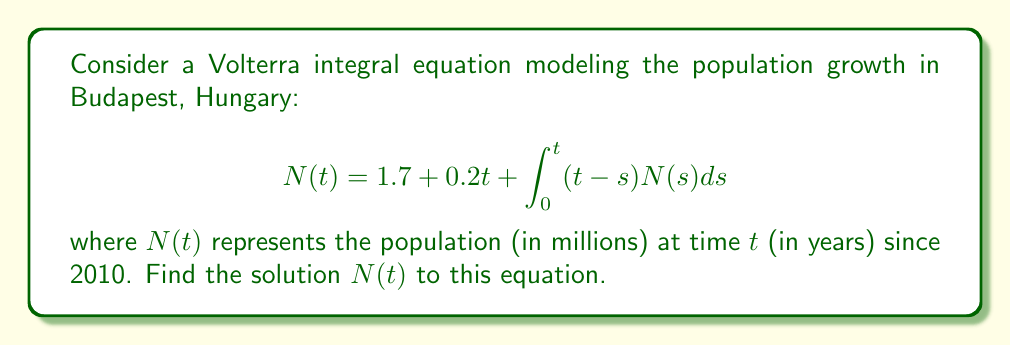Can you answer this question? To solve this Volterra integral equation, we'll use the method of successive approximations:

1) First, let's differentiate both sides of the equation:
   $$N'(t) = 0.2 + \int_0^t N(s)ds$$

2) Differentiating again:
   $$N''(t) = N(t)$$

3) Now we have a second-order differential equation. The general solution is:
   $$N(t) = Ae^t + Be^{-t}$$

4) To find $A$ and $B$, we'll use the initial conditions from the original equation:
   At $t=0$: $N(0) = 1.7$
   $N'(0) = 0.2$

5) Substituting these into our general solution:
   $1.7 = A + B$
   $0.2 = A - B$

6) Solving this system of equations:
   $A = 0.95$
   $B = 0.75$

7) Therefore, our solution is:
   $$N(t) = 0.95e^t + 0.75e^{-t}$$

8) We can verify this solution by substituting it back into the original equation.
Answer: $N(t) = 0.95e^t + 0.75e^{-t}$ 